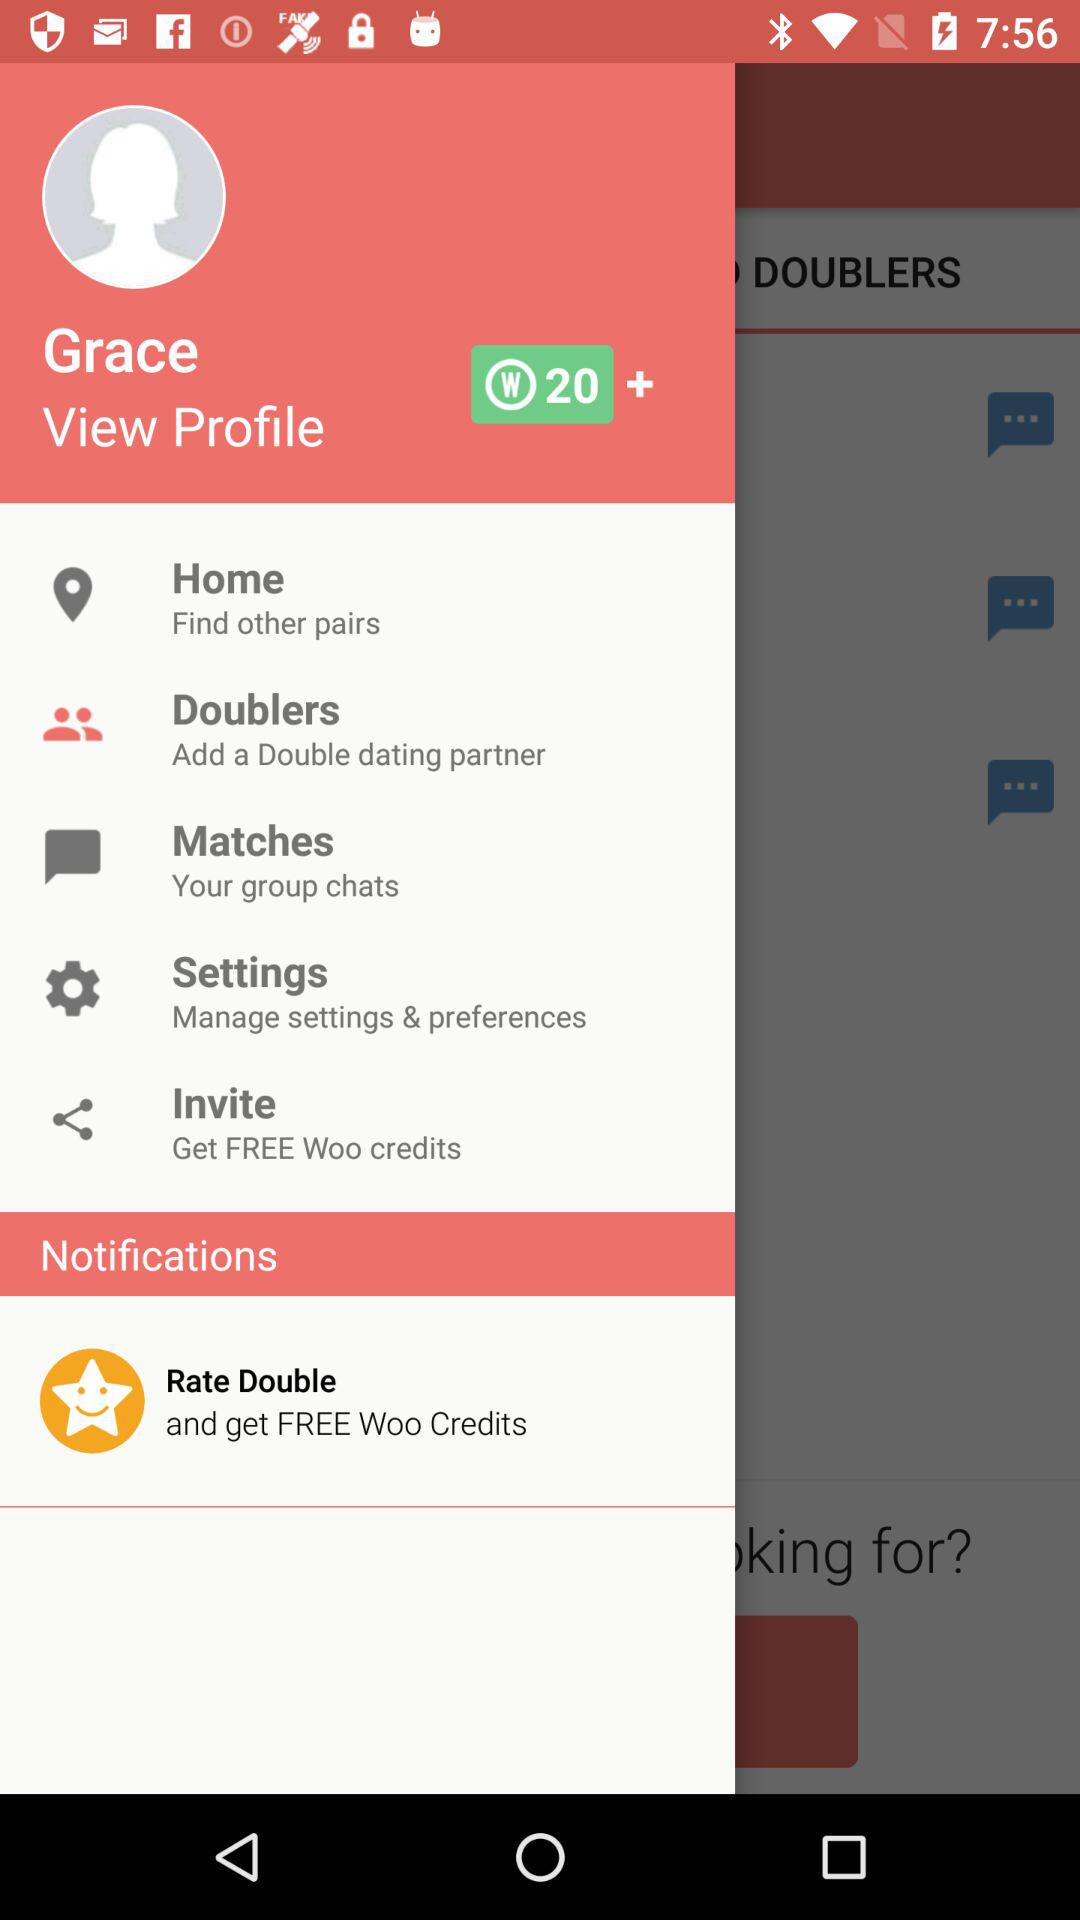How many more Woo credits can I get by inviting a friend?
Answer the question using a single word or phrase. 20 